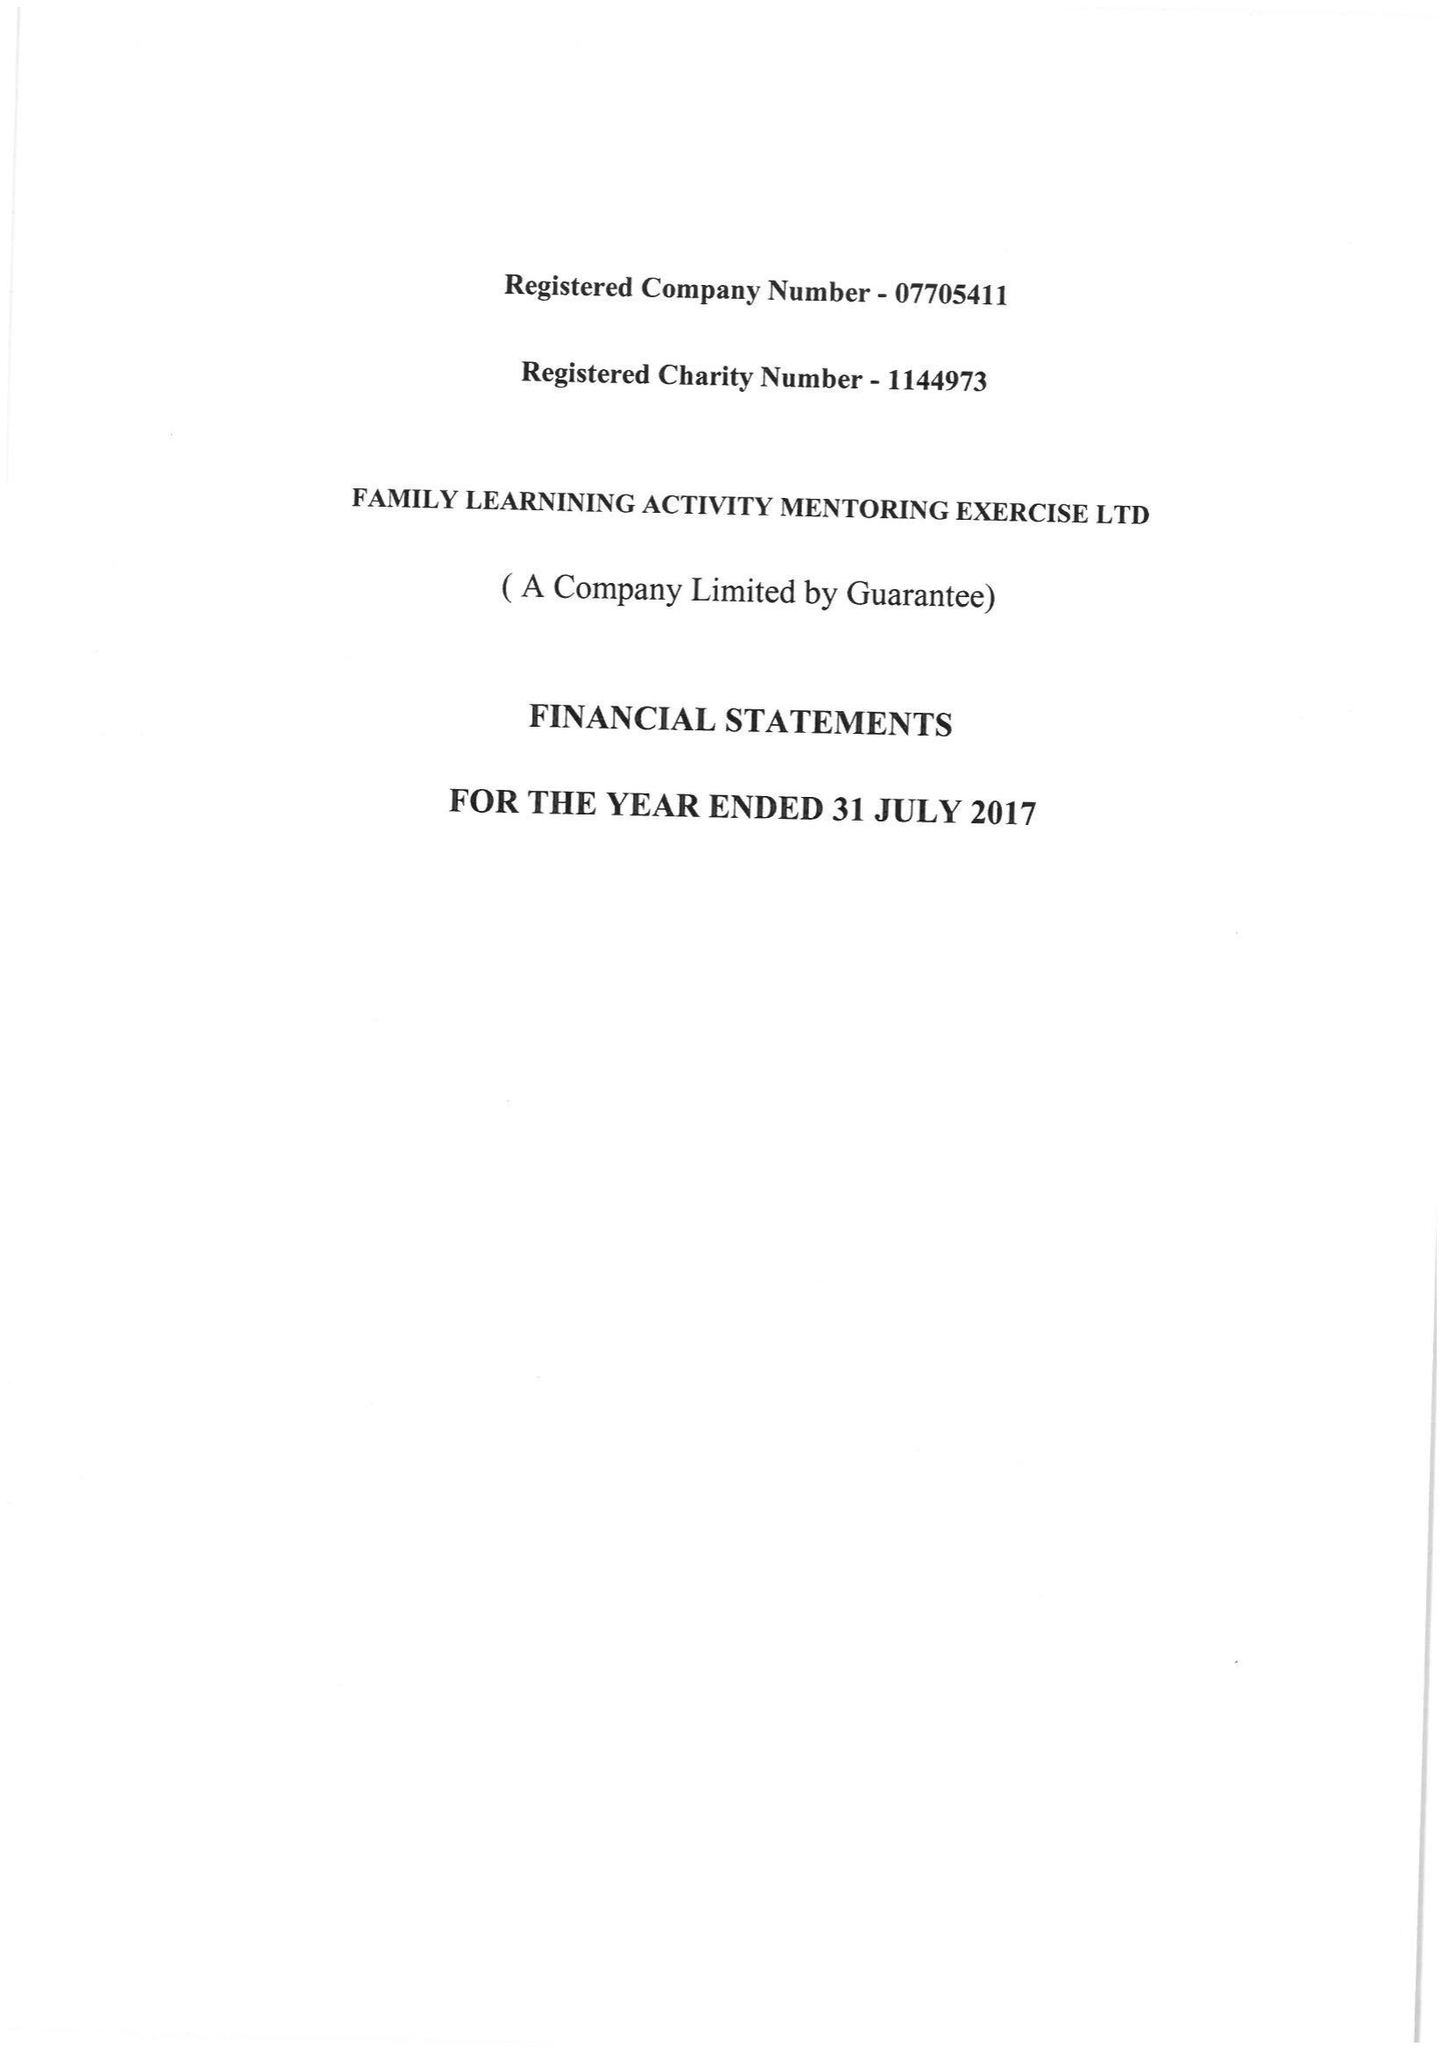What is the value for the address__street_line?
Answer the question using a single word or phrase. THE CURVE 